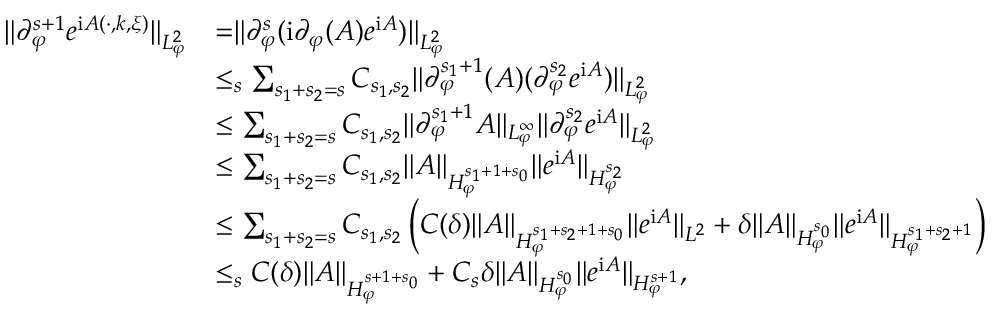<formula> <loc_0><loc_0><loc_500><loc_500>\begin{array} { r l } { \| \partial _ { \varphi } ^ { s + 1 } e ^ { i A ( \cdot , k , \xi ) } \| _ { L _ { \varphi } ^ { 2 } } } & { = \| \partial _ { \varphi } ^ { s } ( i \partial _ { \varphi } ( A ) e ^ { i A } ) \| _ { L _ { \varphi } ^ { 2 } } } \\ & { \leq _ { s } \sum _ { s _ { 1 } + s _ { 2 } = s } C _ { s _ { 1 } , s _ { 2 } } \| \partial _ { \varphi } ^ { s _ { 1 } + 1 } ( A ) ( \partial _ { \varphi } ^ { s _ { 2 } } e ^ { i A } ) \| _ { L _ { \varphi } ^ { 2 } } } \\ & { \leq \sum _ { s _ { 1 } + s _ { 2 } = s } C _ { s _ { 1 } , s _ { 2 } } \| \partial _ { \varphi } ^ { s _ { 1 } + 1 } A \| _ { L _ { \varphi } ^ { \infty } } \| \partial _ { \varphi } ^ { s _ { 2 } } e ^ { i A } \| _ { L _ { \varphi } ^ { 2 } } } \\ & { \leq \sum _ { s _ { 1 } + s _ { 2 } = s } C _ { s _ { 1 } , s _ { 2 } } \| A \| _ { H _ { \varphi } ^ { s _ { 1 } + 1 + s _ { 0 } } } \| e ^ { i A } \| _ { H _ { \varphi } ^ { s _ { 2 } } } } \\ & { \leq \sum _ { s _ { 1 } + s _ { 2 } = s } C _ { s _ { 1 } , s _ { 2 } } \left ( C ( \delta ) \| A \| _ { H _ { \varphi } ^ { s _ { 1 } + s _ { 2 } + 1 + s _ { 0 } } } \| e ^ { i A } \| _ { L ^ { 2 } } + \delta \| A \| _ { H _ { \varphi } ^ { s _ { 0 } } } \| e ^ { i A } \| _ { H _ { \varphi } ^ { s _ { 1 } + s _ { 2 } + 1 } } \right ) } \\ & { \leq _ { s } C ( \delta ) \| { A } \| _ { H _ { \varphi } ^ { s + 1 + s _ { 0 } } } + C _ { s } \delta \| A \| _ { H _ { \varphi } ^ { s _ { 0 } } } \| e ^ { i A } \| _ { H _ { \varphi } ^ { s + 1 } } , } \end{array}</formula> 